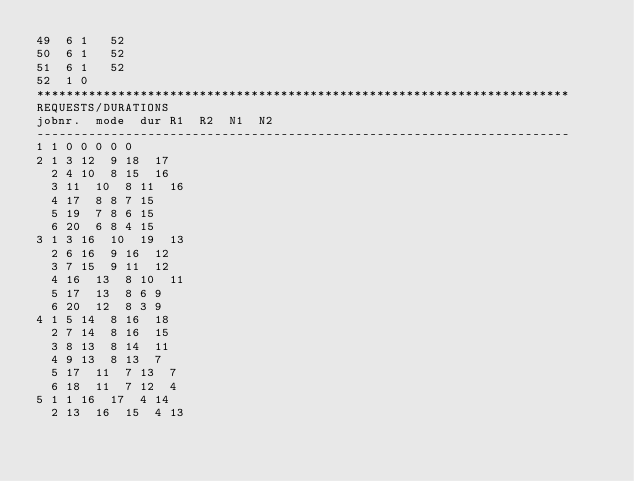Convert code to text. <code><loc_0><loc_0><loc_500><loc_500><_ObjectiveC_>49	6	1		52 
50	6	1		52 
51	6	1		52 
52	1	0		
************************************************************************
REQUESTS/DURATIONS
jobnr.	mode	dur	R1	R2	N1	N2	
------------------------------------------------------------------------
1	1	0	0	0	0	0	
2	1	3	12	9	18	17	
	2	4	10	8	15	16	
	3	11	10	8	11	16	
	4	17	8	8	7	15	
	5	19	7	8	6	15	
	6	20	6	8	4	15	
3	1	3	16	10	19	13	
	2	6	16	9	16	12	
	3	7	15	9	11	12	
	4	16	13	8	10	11	
	5	17	13	8	6	9	
	6	20	12	8	3	9	
4	1	5	14	8	16	18	
	2	7	14	8	16	15	
	3	8	13	8	14	11	
	4	9	13	8	13	7	
	5	17	11	7	13	7	
	6	18	11	7	12	4	
5	1	1	16	17	4	14	
	2	13	16	15	4	13	</code> 